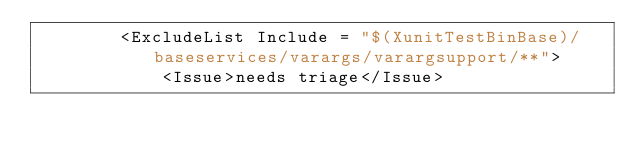Convert code to text. <code><loc_0><loc_0><loc_500><loc_500><_XML_>        <ExcludeList Include = "$(XunitTestBinBase)/baseservices/varargs/varargsupport/**">
            <Issue>needs triage</Issue></code> 